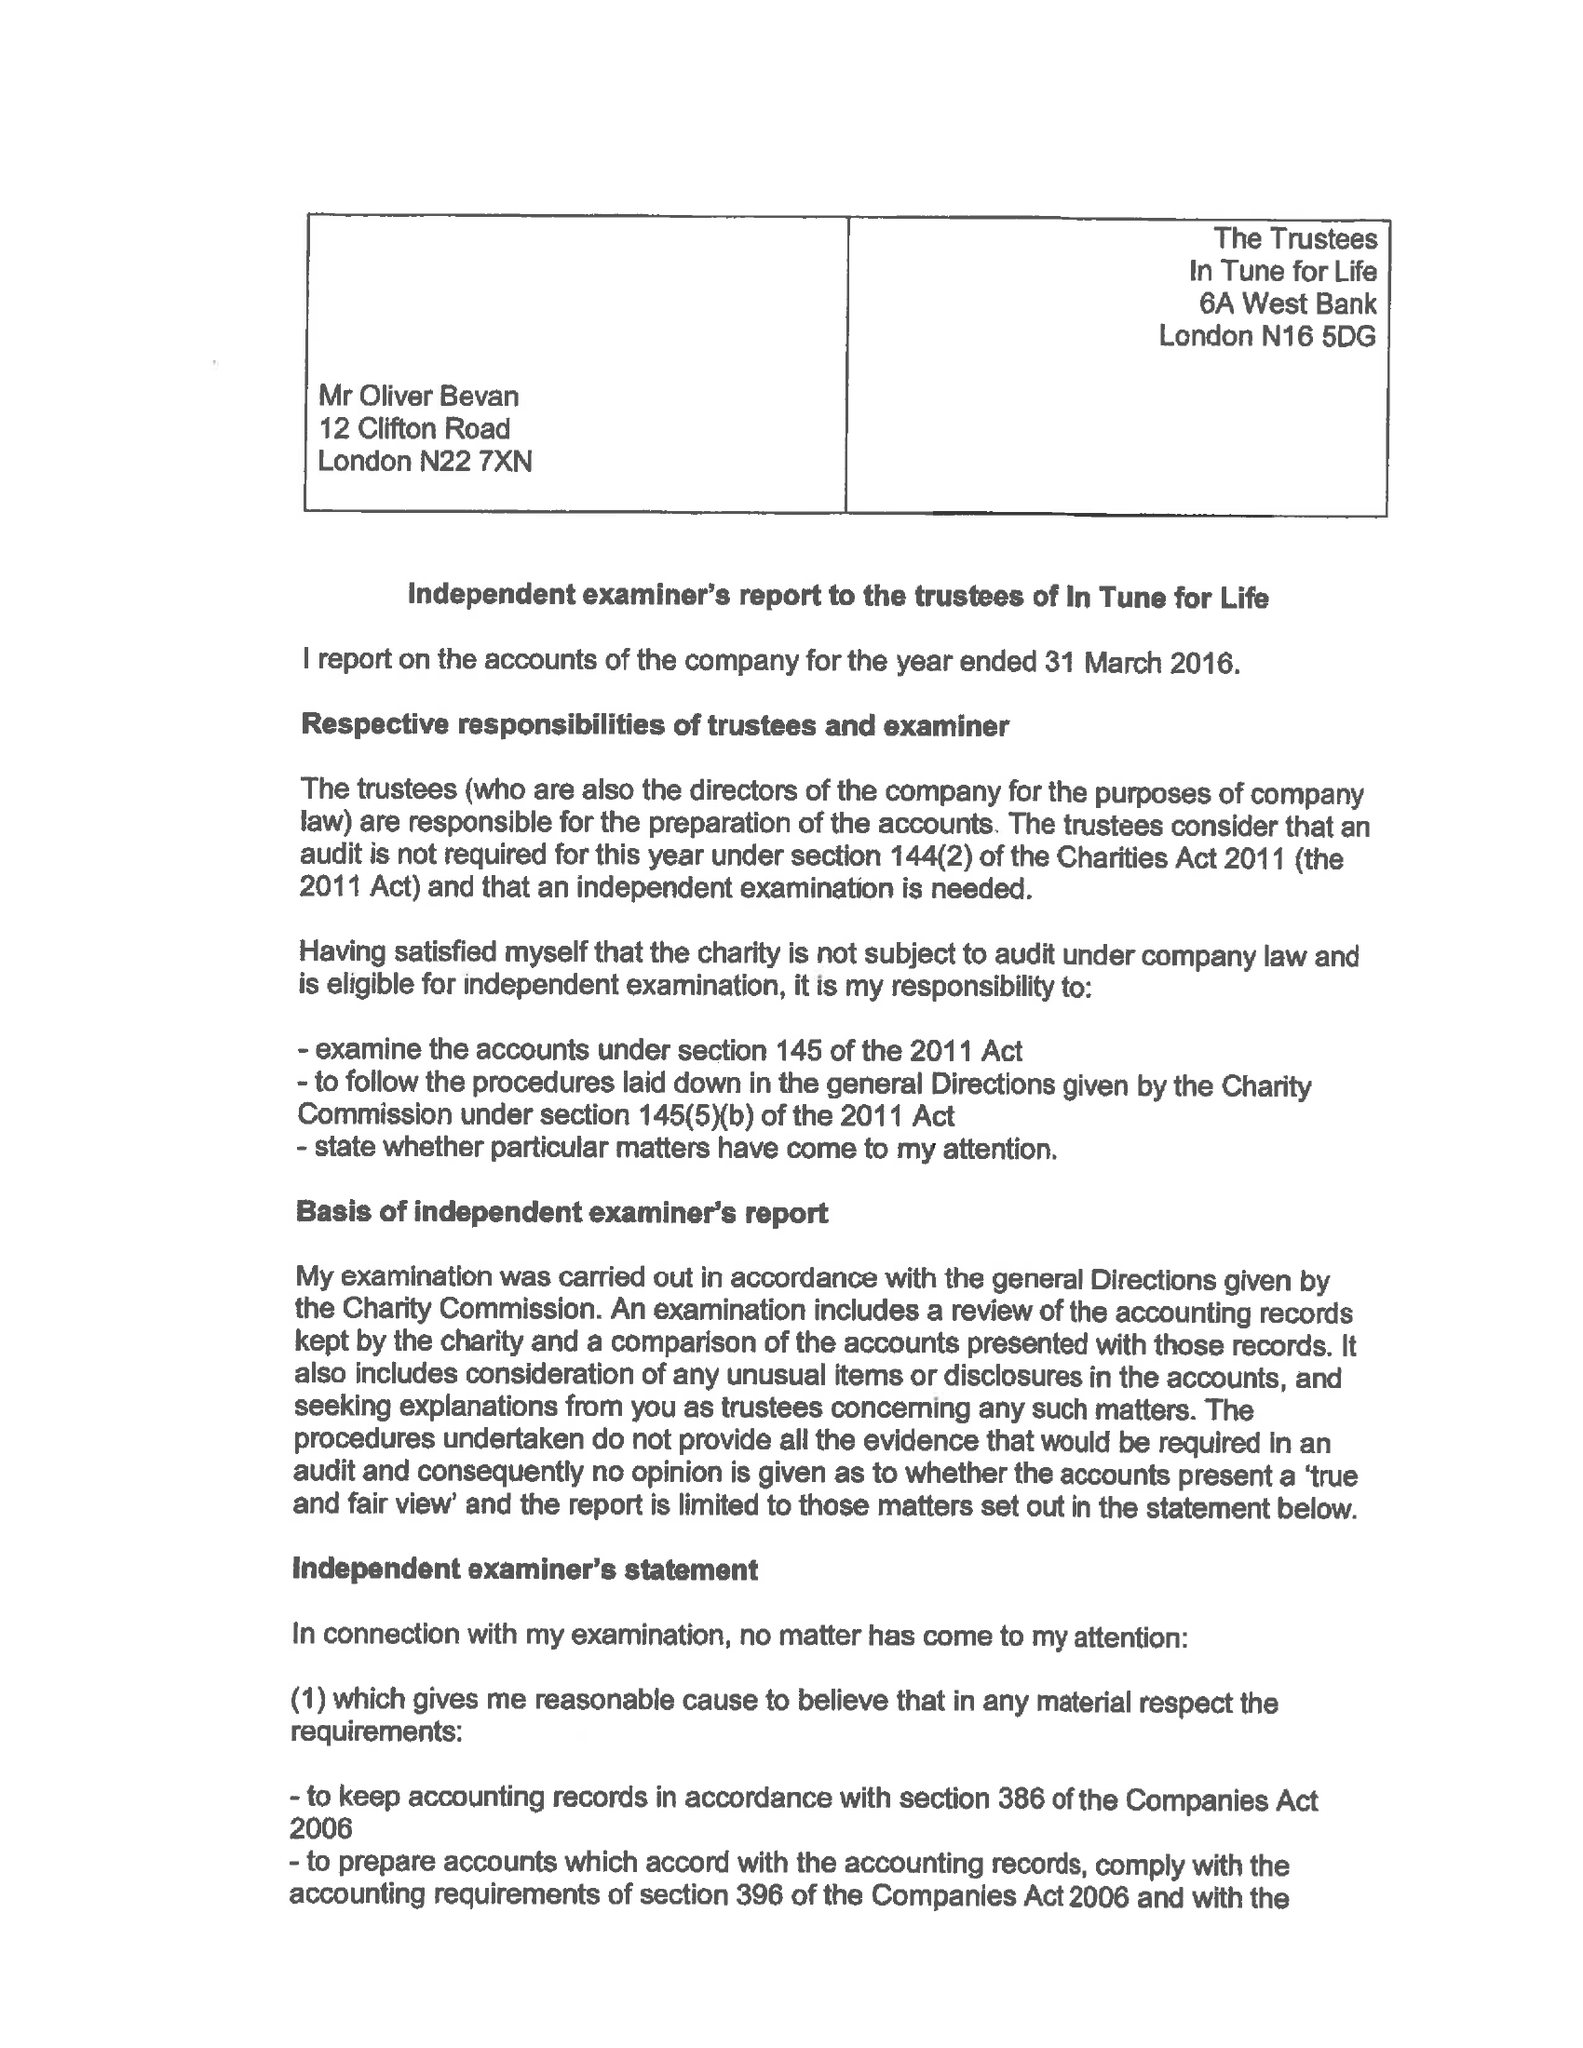What is the value for the charity_number?
Answer the question using a single word or phrase. 1144372 